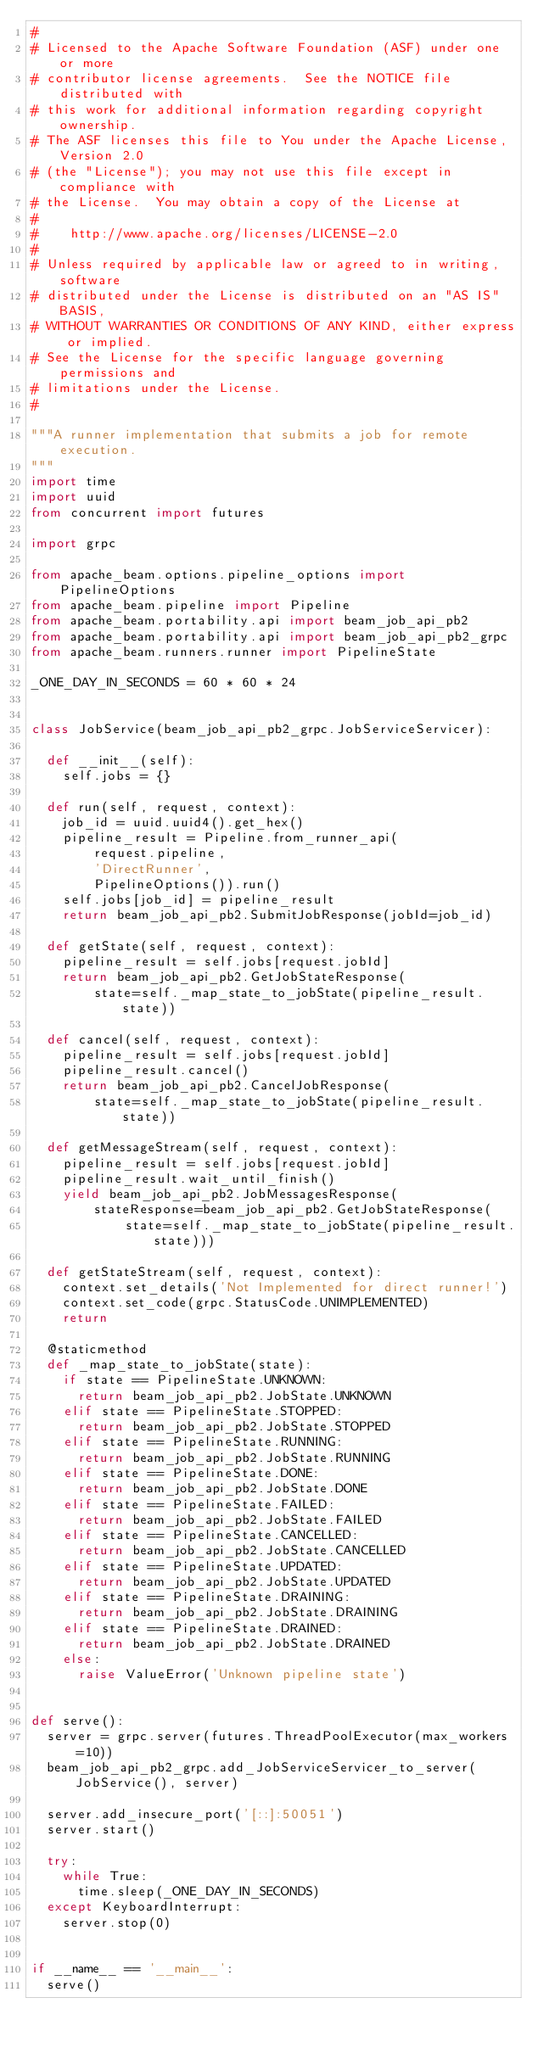Convert code to text. <code><loc_0><loc_0><loc_500><loc_500><_Python_>#
# Licensed to the Apache Software Foundation (ASF) under one or more
# contributor license agreements.  See the NOTICE file distributed with
# this work for additional information regarding copyright ownership.
# The ASF licenses this file to You under the Apache License, Version 2.0
# (the "License"); you may not use this file except in compliance with
# the License.  You may obtain a copy of the License at
#
#    http://www.apache.org/licenses/LICENSE-2.0
#
# Unless required by applicable law or agreed to in writing, software
# distributed under the License is distributed on an "AS IS" BASIS,
# WITHOUT WARRANTIES OR CONDITIONS OF ANY KIND, either express or implied.
# See the License for the specific language governing permissions and
# limitations under the License.
#

"""A runner implementation that submits a job for remote execution.
"""
import time
import uuid
from concurrent import futures

import grpc

from apache_beam.options.pipeline_options import PipelineOptions
from apache_beam.pipeline import Pipeline
from apache_beam.portability.api import beam_job_api_pb2
from apache_beam.portability.api import beam_job_api_pb2_grpc
from apache_beam.runners.runner import PipelineState

_ONE_DAY_IN_SECONDS = 60 * 60 * 24


class JobService(beam_job_api_pb2_grpc.JobServiceServicer):

  def __init__(self):
    self.jobs = {}

  def run(self, request, context):
    job_id = uuid.uuid4().get_hex()
    pipeline_result = Pipeline.from_runner_api(
        request.pipeline,
        'DirectRunner',
        PipelineOptions()).run()
    self.jobs[job_id] = pipeline_result
    return beam_job_api_pb2.SubmitJobResponse(jobId=job_id)

  def getState(self, request, context):
    pipeline_result = self.jobs[request.jobId]
    return beam_job_api_pb2.GetJobStateResponse(
        state=self._map_state_to_jobState(pipeline_result.state))

  def cancel(self, request, context):
    pipeline_result = self.jobs[request.jobId]
    pipeline_result.cancel()
    return beam_job_api_pb2.CancelJobResponse(
        state=self._map_state_to_jobState(pipeline_result.state))

  def getMessageStream(self, request, context):
    pipeline_result = self.jobs[request.jobId]
    pipeline_result.wait_until_finish()
    yield beam_job_api_pb2.JobMessagesResponse(
        stateResponse=beam_job_api_pb2.GetJobStateResponse(
            state=self._map_state_to_jobState(pipeline_result.state)))

  def getStateStream(self, request, context):
    context.set_details('Not Implemented for direct runner!')
    context.set_code(grpc.StatusCode.UNIMPLEMENTED)
    return

  @staticmethod
  def _map_state_to_jobState(state):
    if state == PipelineState.UNKNOWN:
      return beam_job_api_pb2.JobState.UNKNOWN
    elif state == PipelineState.STOPPED:
      return beam_job_api_pb2.JobState.STOPPED
    elif state == PipelineState.RUNNING:
      return beam_job_api_pb2.JobState.RUNNING
    elif state == PipelineState.DONE:
      return beam_job_api_pb2.JobState.DONE
    elif state == PipelineState.FAILED:
      return beam_job_api_pb2.JobState.FAILED
    elif state == PipelineState.CANCELLED:
      return beam_job_api_pb2.JobState.CANCELLED
    elif state == PipelineState.UPDATED:
      return beam_job_api_pb2.JobState.UPDATED
    elif state == PipelineState.DRAINING:
      return beam_job_api_pb2.JobState.DRAINING
    elif state == PipelineState.DRAINED:
      return beam_job_api_pb2.JobState.DRAINED
    else:
      raise ValueError('Unknown pipeline state')


def serve():
  server = grpc.server(futures.ThreadPoolExecutor(max_workers=10))
  beam_job_api_pb2_grpc.add_JobServiceServicer_to_server(JobService(), server)

  server.add_insecure_port('[::]:50051')
  server.start()

  try:
    while True:
      time.sleep(_ONE_DAY_IN_SECONDS)
  except KeyboardInterrupt:
    server.stop(0)


if __name__ == '__main__':
  serve()
</code> 